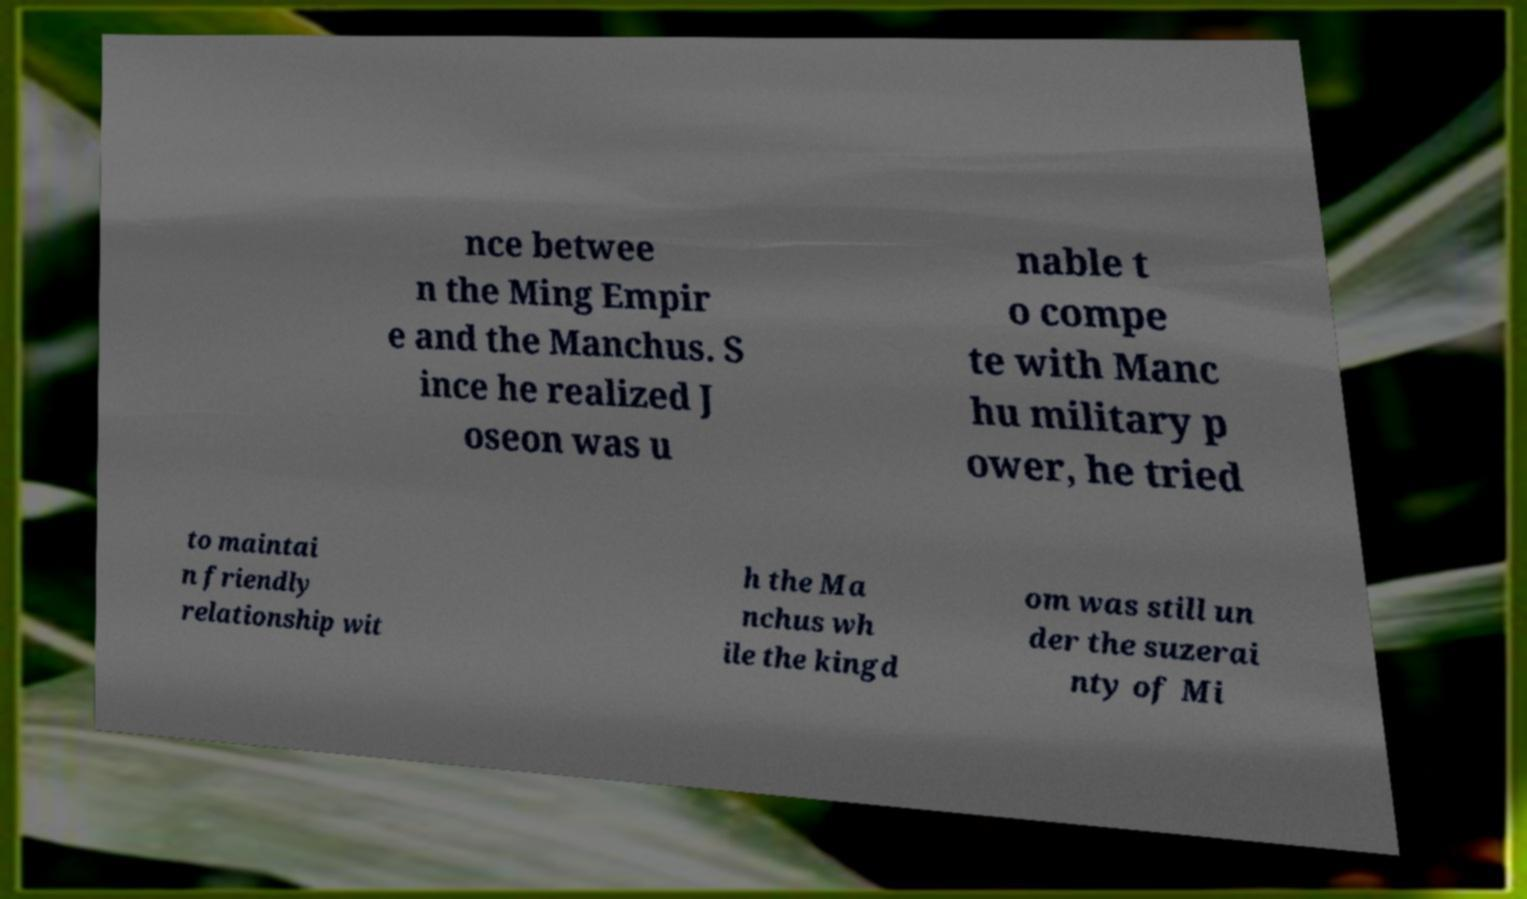Can you read and provide the text displayed in the image?This photo seems to have some interesting text. Can you extract and type it out for me? nce betwee n the Ming Empir e and the Manchus. S ince he realized J oseon was u nable t o compe te with Manc hu military p ower, he tried to maintai n friendly relationship wit h the Ma nchus wh ile the kingd om was still un der the suzerai nty of Mi 